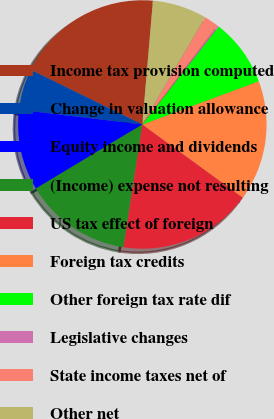Convert chart. <chart><loc_0><loc_0><loc_500><loc_500><pie_chart><fcel>Income tax provision computed<fcel>Change in valuation allowance<fcel>Equity income and dividends<fcel>(Income) expense not resulting<fcel>US tax effect of foreign<fcel>Foreign tax credits<fcel>Other foreign tax rate dif<fcel>Legislative changes<fcel>State income taxes net of<fcel>Other net<nl><fcel>19.12%<fcel>5.35%<fcel>10.52%<fcel>13.96%<fcel>17.4%<fcel>15.68%<fcel>8.8%<fcel>0.19%<fcel>1.91%<fcel>7.08%<nl></chart> 